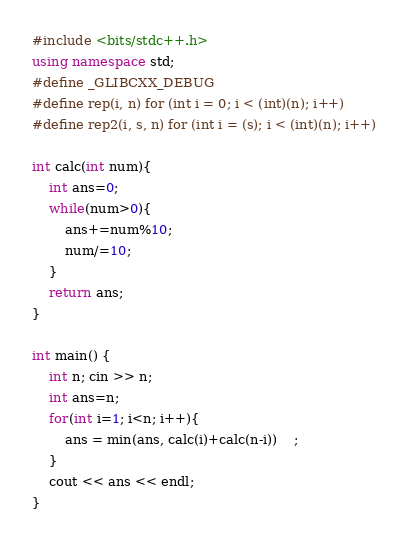Convert code to text. <code><loc_0><loc_0><loc_500><loc_500><_C++_>#include <bits/stdc++.h>
using namespace std;
#define _GLIBCXX_DEBUG
#define rep(i, n) for (int i = 0; i < (int)(n); i++)
#define rep2(i, s, n) for (int i = (s); i < (int)(n); i++)

int calc(int num){
	int ans=0;
	while(num>0){
		ans+=num%10;
		num/=10;
	}
	return ans;
}

int main() {
	int n; cin >> n;
	int ans=n;
	for(int i=1; i<n; i++){
		ans = min(ans, calc(i)+calc(n-i))	;
	}
	cout << ans << endl;
}

</code> 